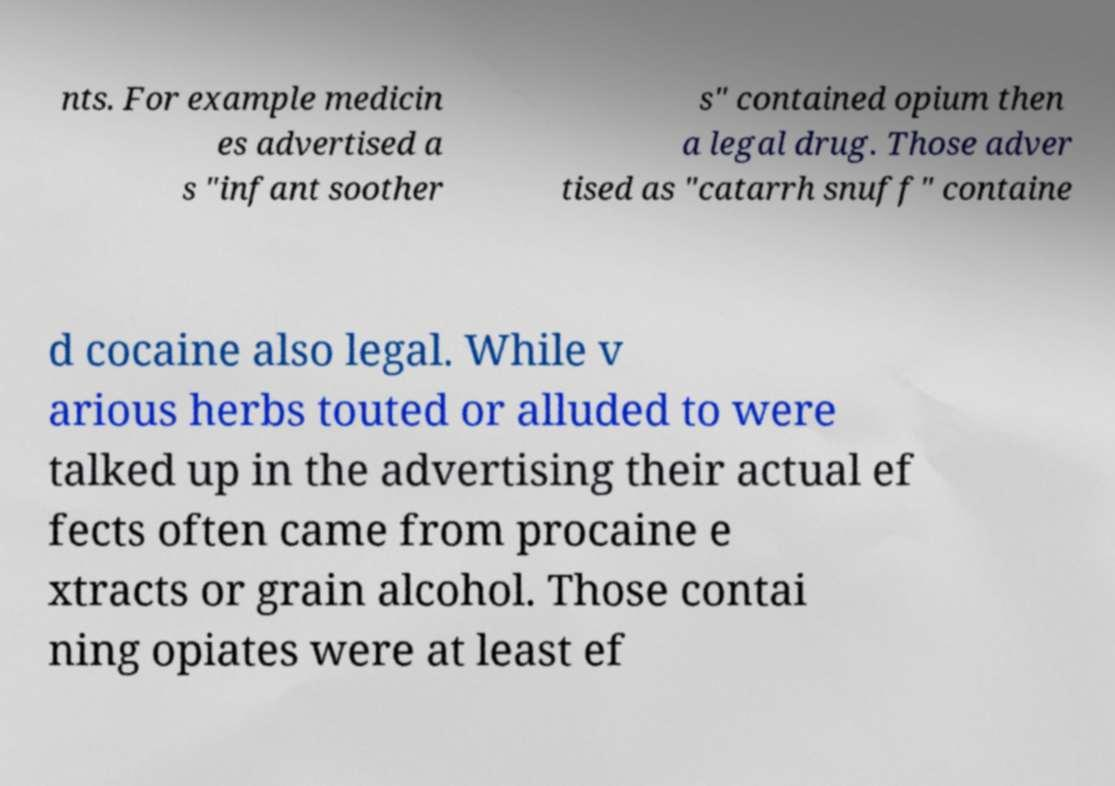What messages or text are displayed in this image? I need them in a readable, typed format. nts. For example medicin es advertised a s "infant soother s" contained opium then a legal drug. Those adver tised as "catarrh snuff" containe d cocaine also legal. While v arious herbs touted or alluded to were talked up in the advertising their actual ef fects often came from procaine e xtracts or grain alcohol. Those contai ning opiates were at least ef 